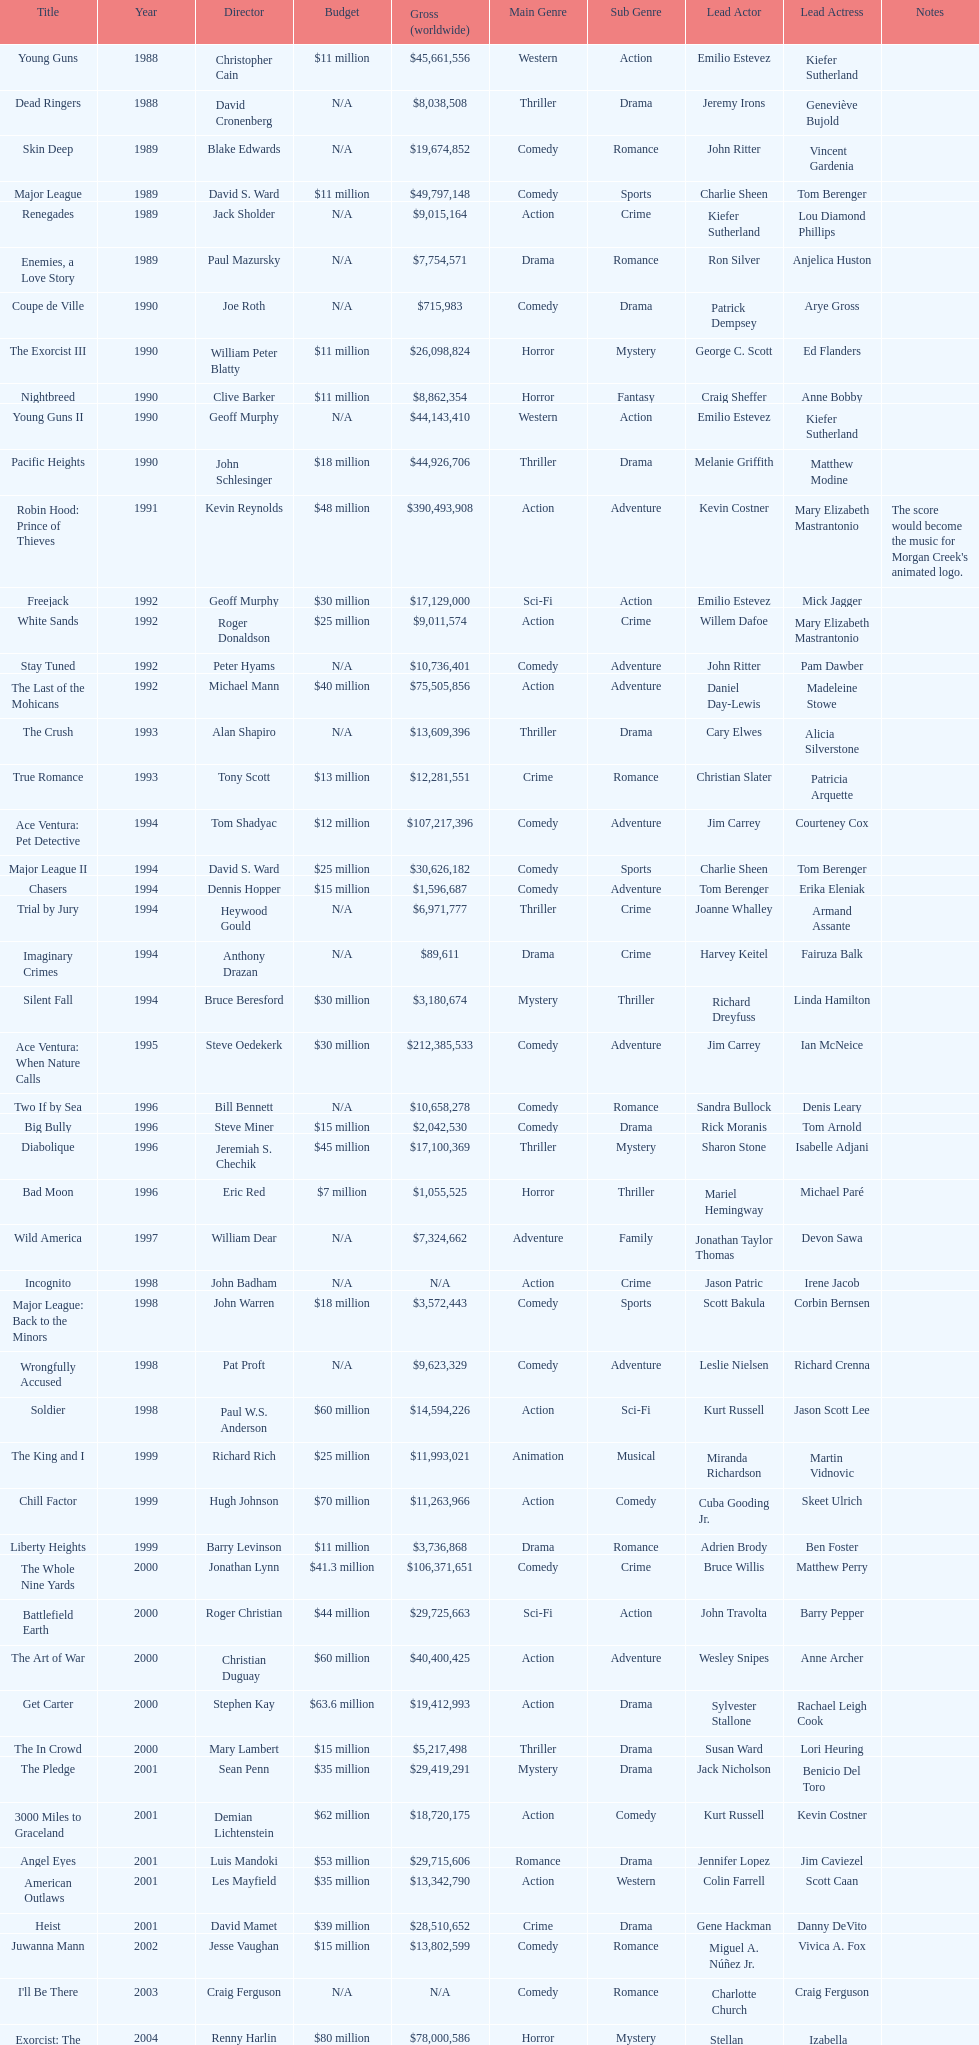Which morgan creek film grossed the most worldwide? Robin Hood: Prince of Thieves. 